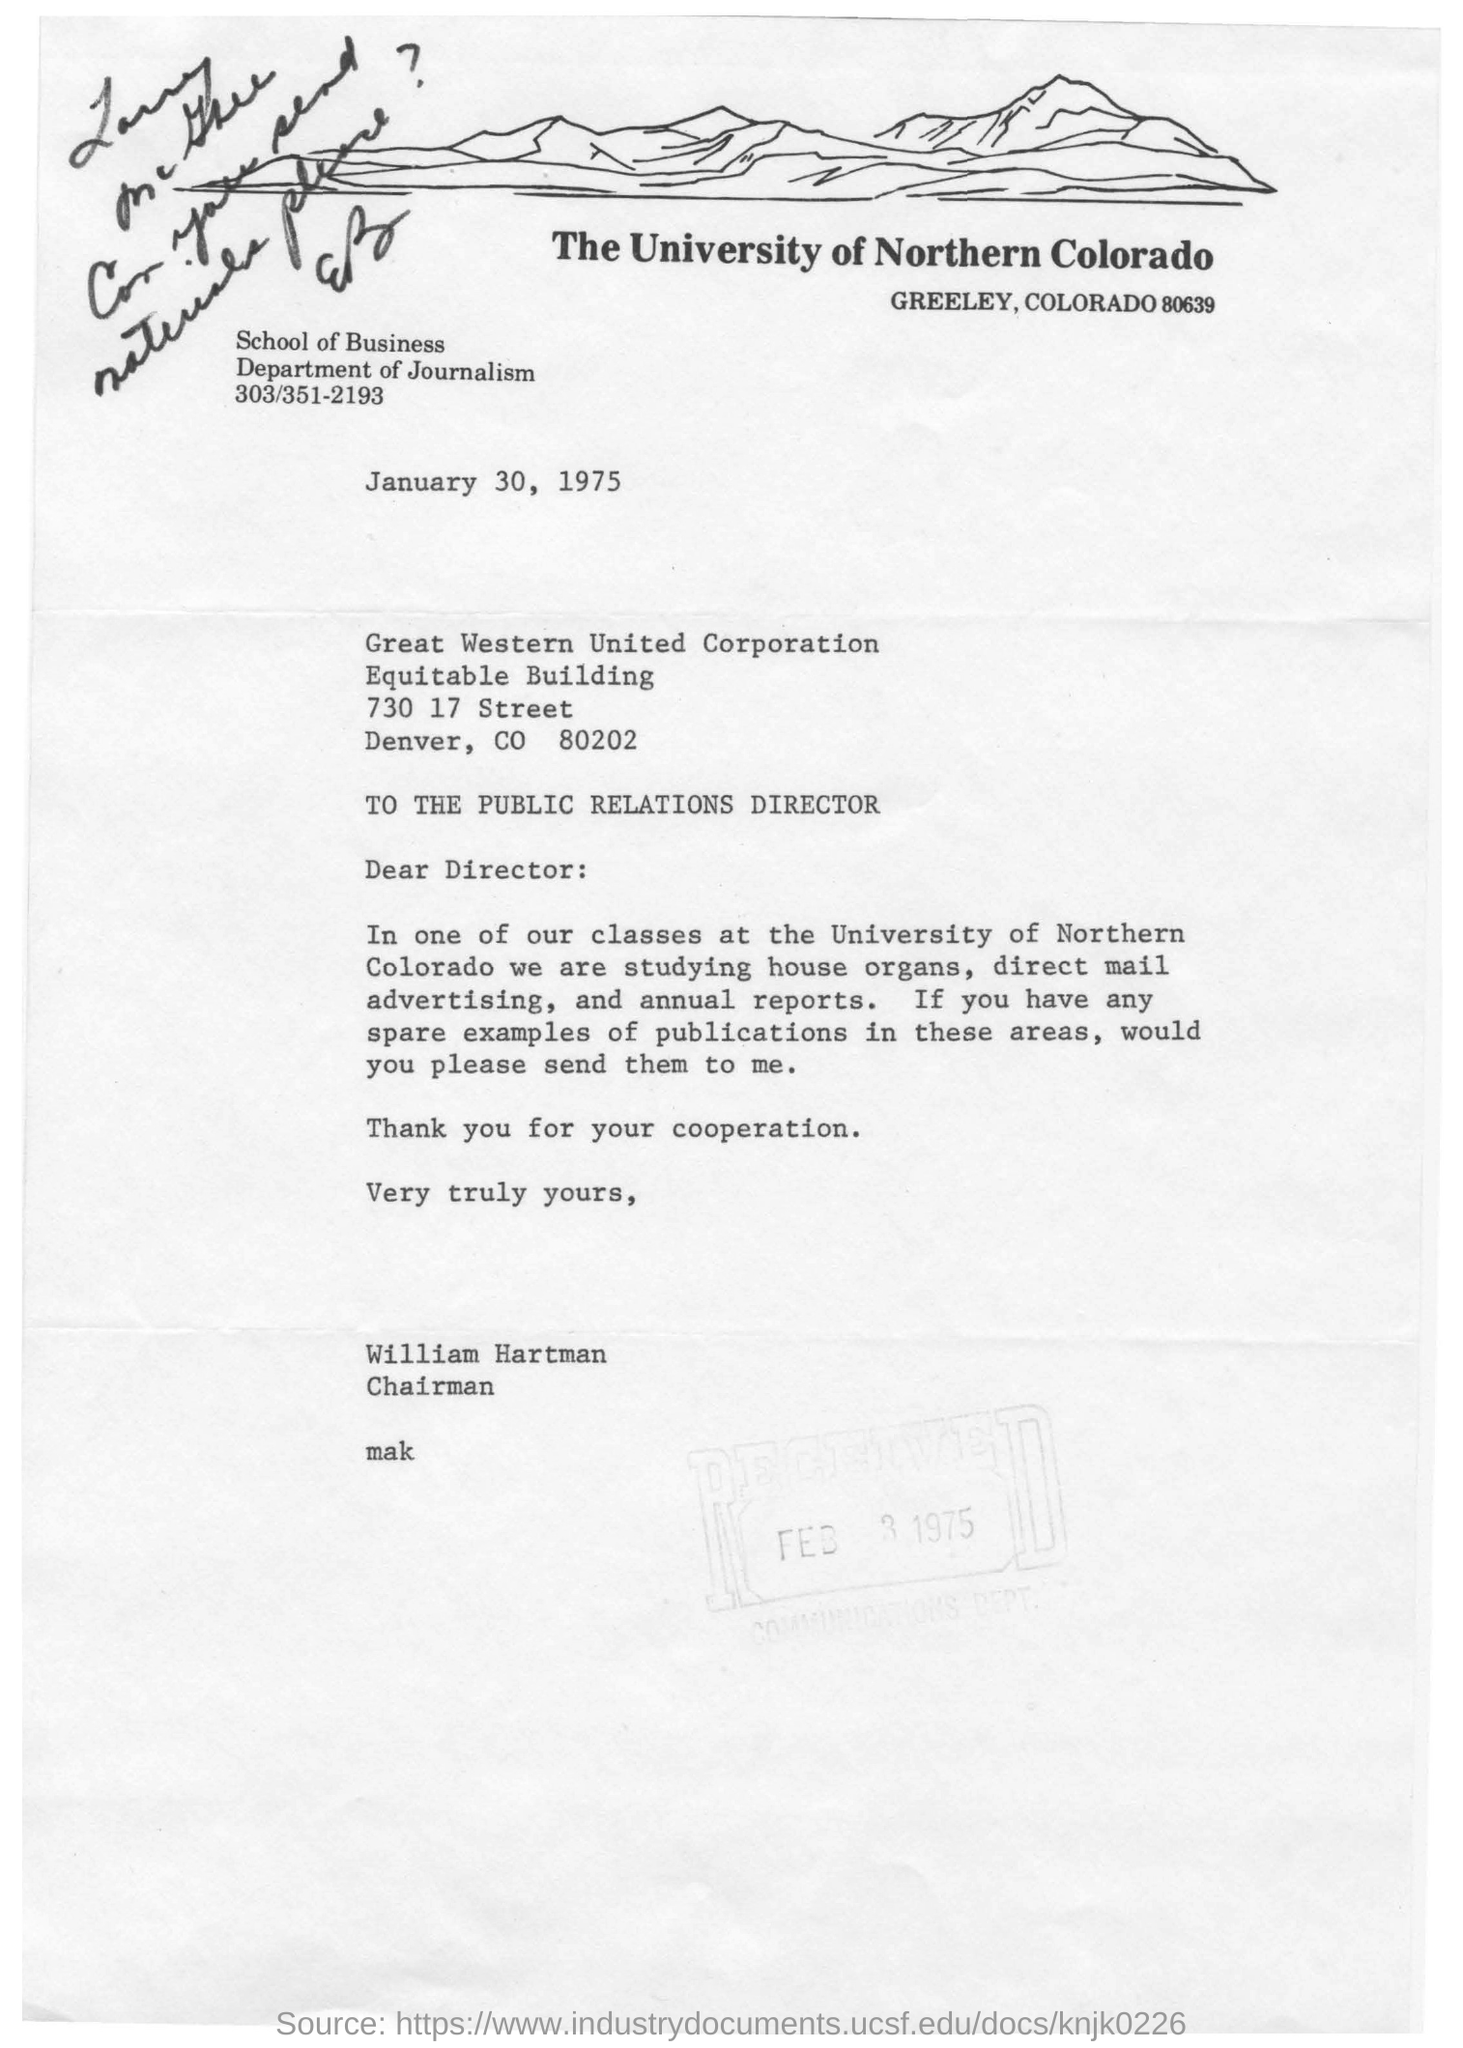Which university is mentioned in the letter head?
Your answer should be compact. The University of Northern Colorado. What is the date mentioned in this letter?
Offer a very short reply. January 30, 1975. To whom, the letter is addressed?
Give a very brief answer. THE PUBLIC RELATIONS DIRECTOR. Who is the sender of this letter?
Make the answer very short. William Hartman. What is the designation of William Hartman?
Your answer should be compact. Chairman. 